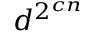Convert formula to latex. <formula><loc_0><loc_0><loc_500><loc_500>d ^ { 2 ^ { c n } }</formula> 